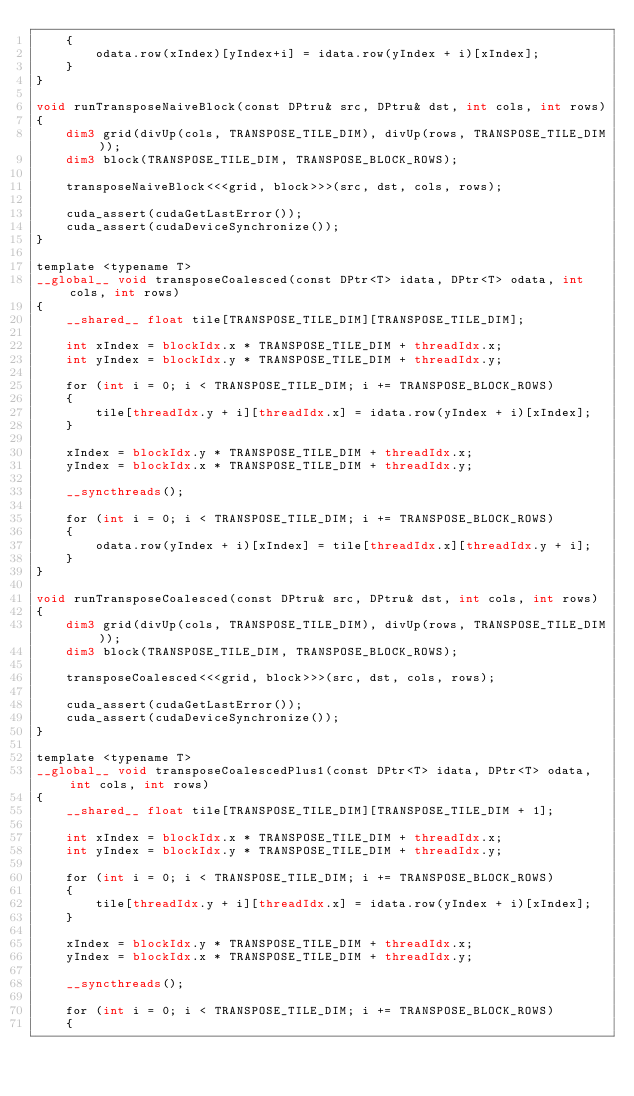Convert code to text. <code><loc_0><loc_0><loc_500><loc_500><_Cuda_>    {
        odata.row(xIndex)[yIndex+i] = idata.row(yIndex + i)[xIndex];
    }
}

void runTransposeNaiveBlock(const DPtru& src, DPtru& dst, int cols, int rows)
{
    dim3 grid(divUp(cols, TRANSPOSE_TILE_DIM), divUp(rows, TRANSPOSE_TILE_DIM));
    dim3 block(TRANSPOSE_TILE_DIM, TRANSPOSE_BLOCK_ROWS);

    transposeNaiveBlock<<<grid, block>>>(src, dst, cols, rows);

    cuda_assert(cudaGetLastError());
    cuda_assert(cudaDeviceSynchronize());
}

template <typename T>
__global__ void transposeCoalesced(const DPtr<T> idata, DPtr<T> odata, int cols, int rows)
{
    __shared__ float tile[TRANSPOSE_TILE_DIM][TRANSPOSE_TILE_DIM];

    int xIndex = blockIdx.x * TRANSPOSE_TILE_DIM + threadIdx.x;
    int yIndex = blockIdx.y * TRANSPOSE_TILE_DIM + threadIdx.y;

    for (int i = 0; i < TRANSPOSE_TILE_DIM; i += TRANSPOSE_BLOCK_ROWS)
    {
        tile[threadIdx.y + i][threadIdx.x] = idata.row(yIndex + i)[xIndex];
    }

    xIndex = blockIdx.y * TRANSPOSE_TILE_DIM + threadIdx.x;
    yIndex = blockIdx.x * TRANSPOSE_TILE_DIM + threadIdx.y;

    __syncthreads();

    for (int i = 0; i < TRANSPOSE_TILE_DIM; i += TRANSPOSE_BLOCK_ROWS)
    {
        odata.row(yIndex + i)[xIndex] = tile[threadIdx.x][threadIdx.y + i];
    }
}

void runTransposeCoalesced(const DPtru& src, DPtru& dst, int cols, int rows)
{
    dim3 grid(divUp(cols, TRANSPOSE_TILE_DIM), divUp(rows, TRANSPOSE_TILE_DIM));
    dim3 block(TRANSPOSE_TILE_DIM, TRANSPOSE_BLOCK_ROWS);

    transposeCoalesced<<<grid, block>>>(src, dst, cols, rows);

    cuda_assert(cudaGetLastError());
    cuda_assert(cudaDeviceSynchronize());
}

template <typename T>
__global__ void transposeCoalescedPlus1(const DPtr<T> idata, DPtr<T> odata, int cols, int rows)
{
    __shared__ float tile[TRANSPOSE_TILE_DIM][TRANSPOSE_TILE_DIM + 1];

    int xIndex = blockIdx.x * TRANSPOSE_TILE_DIM + threadIdx.x;
    int yIndex = blockIdx.y * TRANSPOSE_TILE_DIM + threadIdx.y;

    for (int i = 0; i < TRANSPOSE_TILE_DIM; i += TRANSPOSE_BLOCK_ROWS)
    {
        tile[threadIdx.y + i][threadIdx.x] = idata.row(yIndex + i)[xIndex];
    }

    xIndex = blockIdx.y * TRANSPOSE_TILE_DIM + threadIdx.x;
    yIndex = blockIdx.x * TRANSPOSE_TILE_DIM + threadIdx.y;

    __syncthreads();

    for (int i = 0; i < TRANSPOSE_TILE_DIM; i += TRANSPOSE_BLOCK_ROWS)
    {</code> 